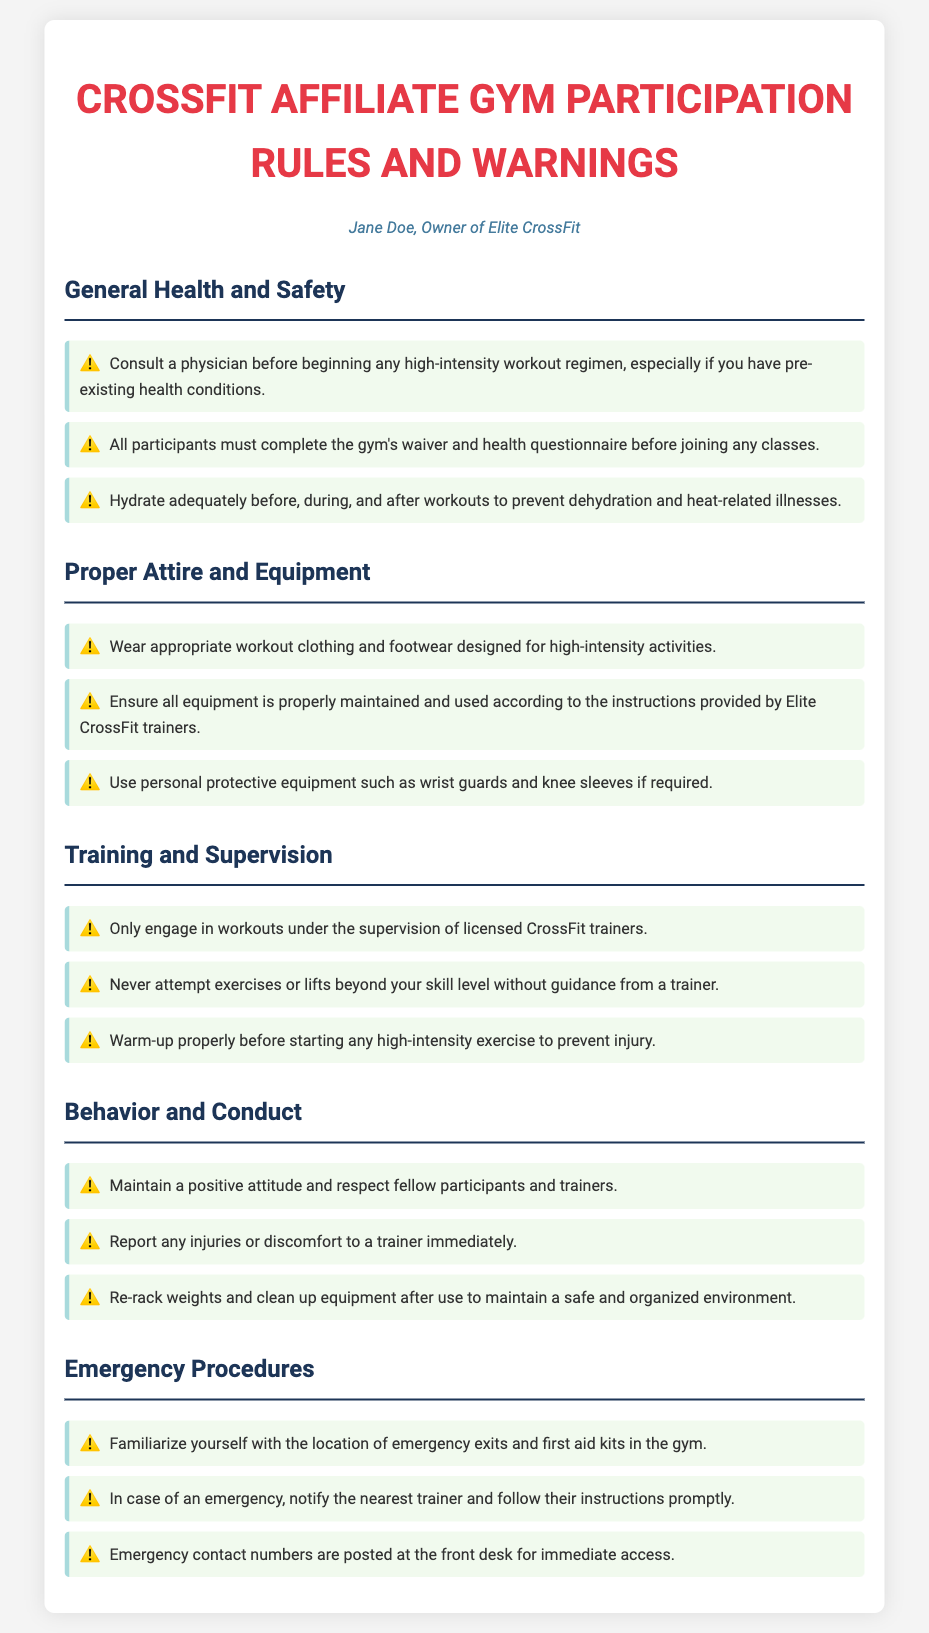What should participants do before beginning workouts? Participants should consult a physician before beginning any high-intensity workout regimen.
Answer: Consult a physician What must all participants complete before joining classes? All participants must complete the gym's waiver and health questionnaire before joining any classes.
Answer: Waiver and health questionnaire What type of clothing is required during workouts? Participants must wear appropriate workout clothing and footwear designed for high-intensity activities.
Answer: Appropriate workout clothing and footwear Who should supervise the workouts? Workouts should only be engaged in under the supervision of licensed CrossFit trainers.
Answer: Licensed CrossFit trainers What must participants do with weights after use? Participants must re-rack weights and clean up equipment after use to maintain a safe and organized environment.
Answer: Re-rack weights and clean up equipment What is the first action a participant should take in an emergency? In case of an emergency, the participant should notify the nearest trainer and follow their instructions promptly.
Answer: Notify the nearest trainer 